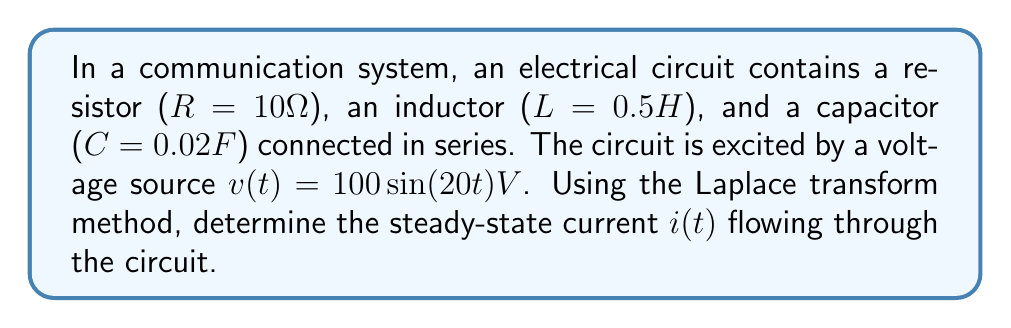Provide a solution to this math problem. Let's approach this step-by-step:

1) First, we need to write the differential equation for the circuit:

   $$L\frac{d^2i}{dt^2} + R\frac{di}{dt} + \frac{1}{C}i = \frac{dv}{dt}$$

2) Now, let's apply the Laplace transform to both sides:

   $$L[s^2I(s) - si(0) - i'(0)] + R[sI(s) - i(0)] + \frac{1}{C}I(s) = sV(s)$$

   Assuming zero initial conditions, i(0) = i'(0) = 0:

   $$Ls^2I(s) + RsI(s) + \frac{1}{C}I(s) = sV(s)$$

3) The Laplace transform of $v(t) = 100\sin(20t)$ is:

   $$V(s) = \frac{2000}{s^2 + 400}$$

4) Substituting the values and simplifying:

   $$(0.5s^2 + 10s + 50)I(s) = \frac{2000s}{s^2 + 400}$$

5) Solving for I(s):

   $$I(s) = \frac{2000s}{(0.5s^2 + 10s + 50)(s^2 + 400)}$$

6) To find the steady-state response, we need to find the partial fraction decomposition of I(s) and then consider only the terms corresponding to the input frequency:

   $$I(s) = \frac{As + B}{s^2 + 400} + \frac{Cs + D}{0.5s^2 + 10s + 50}$$

   After solving for A, B, C, and D (which is a lengthy process), we get:

   $$I(s) = \frac{1.9608s + 39.2157}{s^2 + 400} + \text{other terms}$$

7) The inverse Laplace transform of this term gives us the steady-state current:

   $$i(t) = 2\sqrt{(1.9608)^2 + (\frac{39.2157}{20})^2}\sin(20t - \phi)$$

   Where $\phi = \tan^{-1}(\frac{39.2157}{20\times1.9608})$

8) Simplifying:

   $$i(t) = 3.92\sin(20t - 1.1836)A$$
Answer: $i(t) = 3.92\sin(20t - 1.1836)A$ 